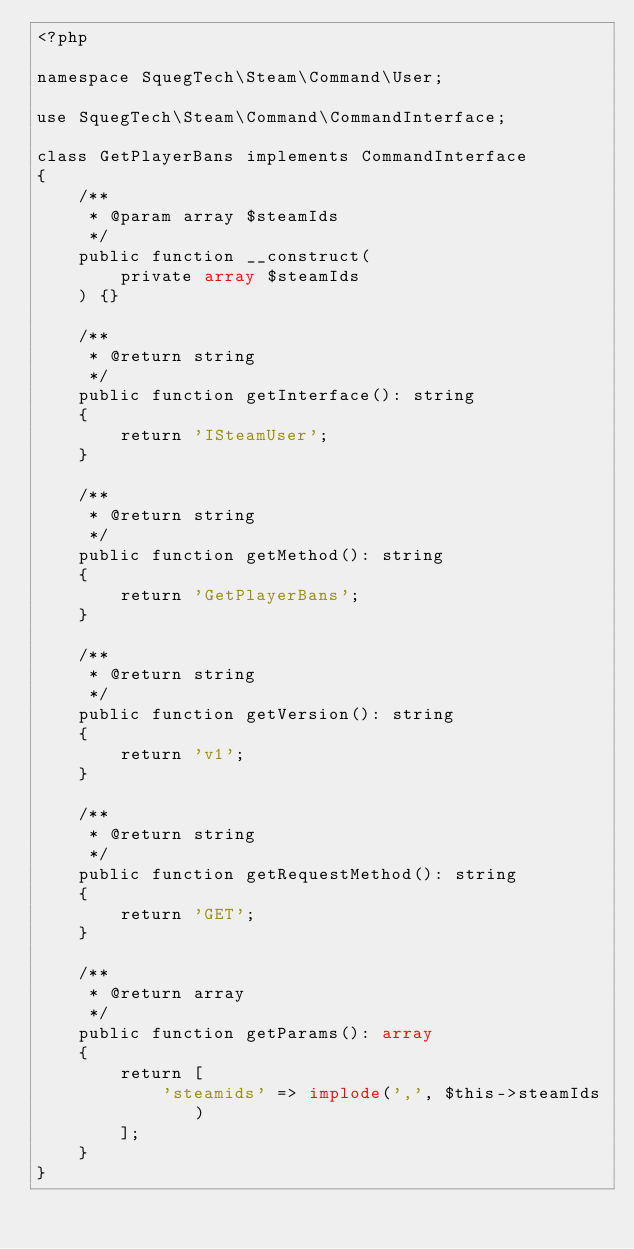<code> <loc_0><loc_0><loc_500><loc_500><_PHP_><?php

namespace SquegTech\Steam\Command\User;

use SquegTech\Steam\Command\CommandInterface;

class GetPlayerBans implements CommandInterface
{
    /**
     * @param array $steamIds
     */
    public function __construct(
        private array $steamIds
    ) {}

    /**
     * @return string
     */
    public function getInterface(): string
    {
        return 'ISteamUser';
    }

    /**
     * @return string
     */
    public function getMethod(): string
    {
        return 'GetPlayerBans';
    }

    /**
     * @return string
     */
    public function getVersion(): string
    {
        return 'v1';
    }

    /**
     * @return string
     */
    public function getRequestMethod(): string
    {
        return 'GET';
    }

    /**
     * @return array
     */
    public function getParams(): array
    {
        return [
            'steamids' => implode(',', $this->steamIds)
        ];
    }
}</code> 